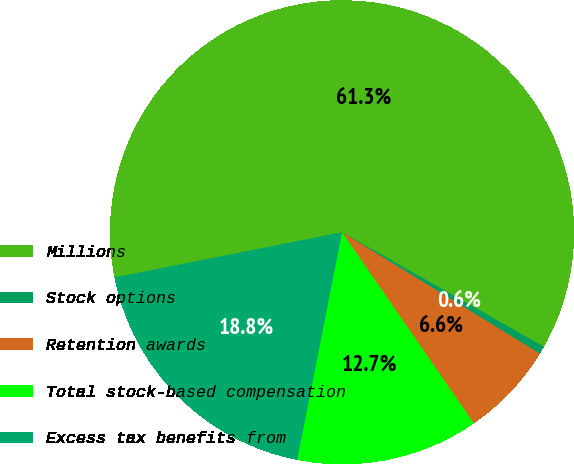Convert chart. <chart><loc_0><loc_0><loc_500><loc_500><pie_chart><fcel>Millions<fcel>Stock options<fcel>Retention awards<fcel>Total stock-based compensation<fcel>Excess tax benefits from<nl><fcel>61.33%<fcel>0.55%<fcel>6.63%<fcel>12.71%<fcel>18.78%<nl></chart> 